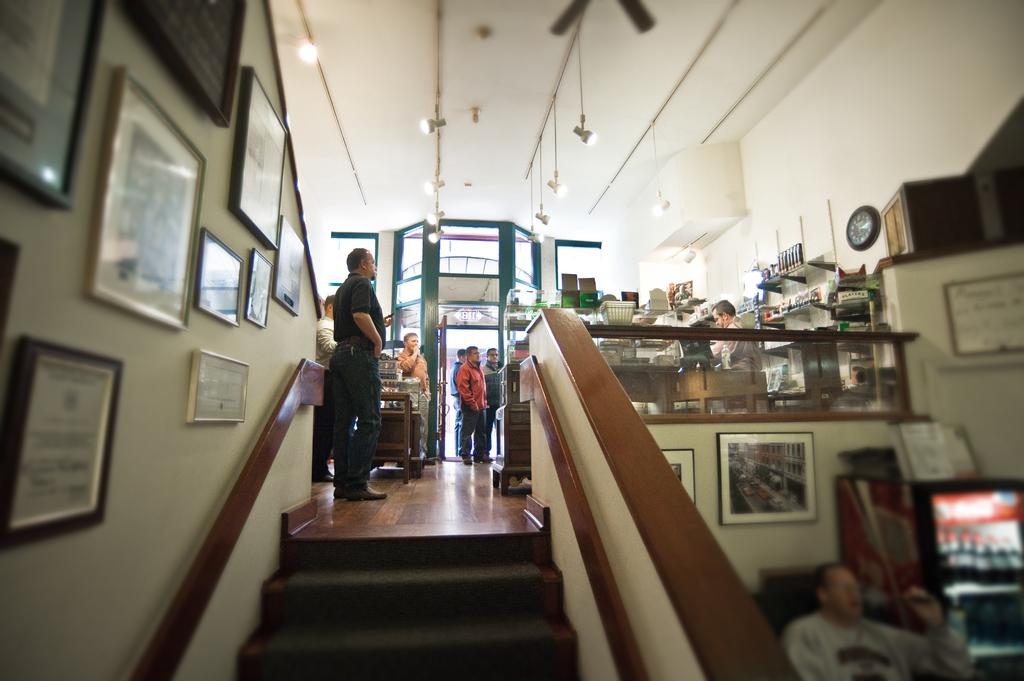What type of structure can be seen in the image? There is a wall in the image. What is hanging on the wall? There is a photo frame in the image. Can you describe the people visible in the image? There are people visible in the image. What architectural feature is present in the image? There are stairs in the image. What type of lighting is present in the image? There are lights in the image. What device is used for air circulation in the image? There is a fan in the image. What type of screw can be seen holding the photo frame in the image? There is no screw visible in the image; the photo frame is hanging on the wall. What type of chess piece is visible on the stairs in the image? There is no chess piece present in the image; the image only shows a wall, a photo frame, people, stairs, lights, and a fan. 